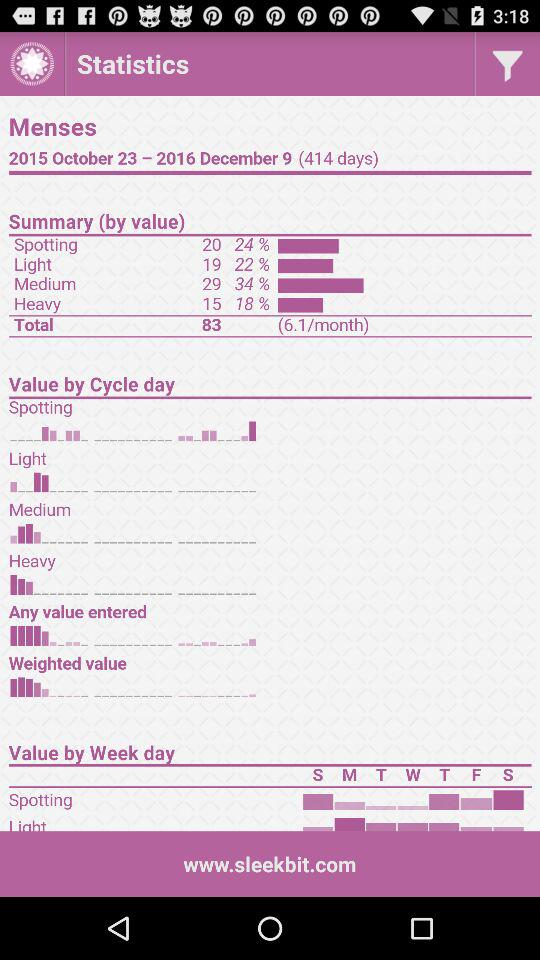What date range is mentioned on the screen? The date range that is mentioned on the screen is 2015 October 23–2016 December 9. 